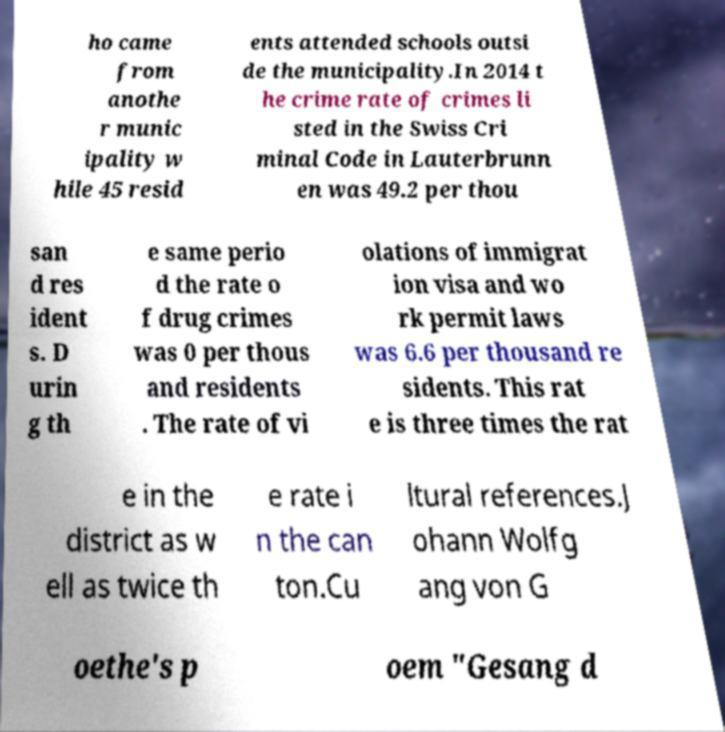Could you extract and type out the text from this image? ho came from anothe r munic ipality w hile 45 resid ents attended schools outsi de the municipality.In 2014 t he crime rate of crimes li sted in the Swiss Cri minal Code in Lauterbrunn en was 49.2 per thou san d res ident s. D urin g th e same perio d the rate o f drug crimes was 0 per thous and residents . The rate of vi olations of immigrat ion visa and wo rk permit laws was 6.6 per thousand re sidents. This rat e is three times the rat e in the district as w ell as twice th e rate i n the can ton.Cu ltural references.J ohann Wolfg ang von G oethe's p oem "Gesang d 